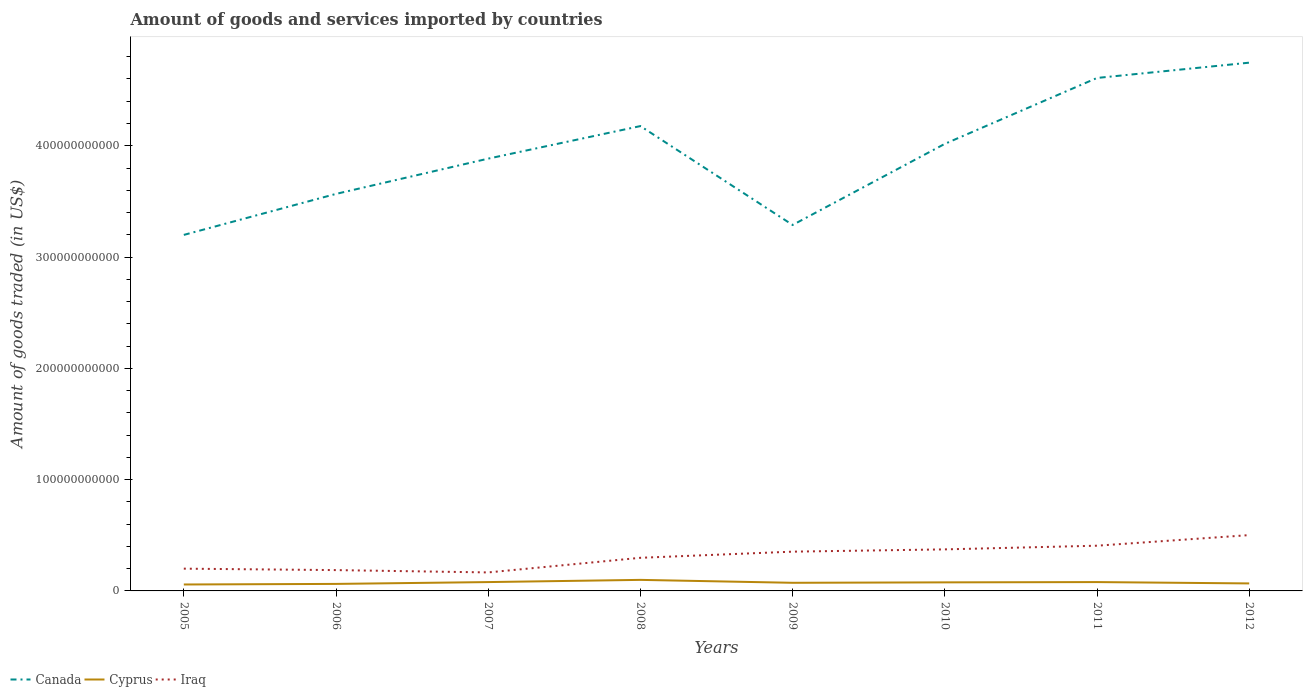How many different coloured lines are there?
Make the answer very short. 3. Is the number of lines equal to the number of legend labels?
Your answer should be compact. Yes. Across all years, what is the maximum total amount of goods and services imported in Iraq?
Your response must be concise. 1.66e+1. In which year was the total amount of goods and services imported in Canada maximum?
Keep it short and to the point. 2005. What is the total total amount of goods and services imported in Cyprus in the graph?
Give a very brief answer. -3.08e+06. What is the difference between the highest and the second highest total amount of goods and services imported in Iraq?
Give a very brief answer. 3.35e+1. Is the total amount of goods and services imported in Canada strictly greater than the total amount of goods and services imported in Iraq over the years?
Make the answer very short. No. What is the difference between two consecutive major ticks on the Y-axis?
Keep it short and to the point. 1.00e+11. Are the values on the major ticks of Y-axis written in scientific E-notation?
Your answer should be very brief. No. Does the graph contain any zero values?
Your answer should be very brief. No. Does the graph contain grids?
Provide a short and direct response. No. Where does the legend appear in the graph?
Your answer should be very brief. Bottom left. What is the title of the graph?
Your response must be concise. Amount of goods and services imported by countries. Does "Argentina" appear as one of the legend labels in the graph?
Offer a very short reply. No. What is the label or title of the X-axis?
Keep it short and to the point. Years. What is the label or title of the Y-axis?
Give a very brief answer. Amount of goods traded (in US$). What is the Amount of goods traded (in US$) of Canada in 2005?
Provide a succinct answer. 3.20e+11. What is the Amount of goods traded (in US$) of Cyprus in 2005?
Offer a very short reply. 5.79e+09. What is the Amount of goods traded (in US$) in Iraq in 2005?
Offer a terse response. 2.00e+1. What is the Amount of goods traded (in US$) of Canada in 2006?
Your response must be concise. 3.57e+11. What is the Amount of goods traded (in US$) of Cyprus in 2006?
Make the answer very short. 6.30e+09. What is the Amount of goods traded (in US$) of Iraq in 2006?
Give a very brief answer. 1.87e+1. What is the Amount of goods traded (in US$) in Canada in 2007?
Offer a terse response. 3.88e+11. What is the Amount of goods traded (in US$) of Cyprus in 2007?
Your answer should be compact. 7.95e+09. What is the Amount of goods traded (in US$) in Iraq in 2007?
Your answer should be very brief. 1.66e+1. What is the Amount of goods traded (in US$) in Canada in 2008?
Ensure brevity in your answer.  4.18e+11. What is the Amount of goods traded (in US$) of Cyprus in 2008?
Your answer should be compact. 9.93e+09. What is the Amount of goods traded (in US$) of Iraq in 2008?
Provide a short and direct response. 2.98e+1. What is the Amount of goods traded (in US$) of Canada in 2009?
Provide a short and direct response. 3.29e+11. What is the Amount of goods traded (in US$) of Cyprus in 2009?
Offer a very short reply. 7.30e+09. What is the Amount of goods traded (in US$) of Iraq in 2009?
Offer a very short reply. 3.53e+1. What is the Amount of goods traded (in US$) in Canada in 2010?
Your answer should be compact. 4.02e+11. What is the Amount of goods traded (in US$) in Cyprus in 2010?
Make the answer very short. 7.69e+09. What is the Amount of goods traded (in US$) of Iraq in 2010?
Provide a short and direct response. 3.73e+1. What is the Amount of goods traded (in US$) of Canada in 2011?
Your answer should be compact. 4.61e+11. What is the Amount of goods traded (in US$) in Cyprus in 2011?
Ensure brevity in your answer.  7.95e+09. What is the Amount of goods traded (in US$) of Iraq in 2011?
Your answer should be compact. 4.06e+1. What is the Amount of goods traded (in US$) in Canada in 2012?
Provide a short and direct response. 4.75e+11. What is the Amount of goods traded (in US$) in Cyprus in 2012?
Your answer should be compact. 6.74e+09. What is the Amount of goods traded (in US$) of Iraq in 2012?
Provide a succinct answer. 5.02e+1. Across all years, what is the maximum Amount of goods traded (in US$) in Canada?
Offer a very short reply. 4.75e+11. Across all years, what is the maximum Amount of goods traded (in US$) of Cyprus?
Provide a succinct answer. 9.93e+09. Across all years, what is the maximum Amount of goods traded (in US$) in Iraq?
Keep it short and to the point. 5.02e+1. Across all years, what is the minimum Amount of goods traded (in US$) of Canada?
Make the answer very short. 3.20e+11. Across all years, what is the minimum Amount of goods traded (in US$) in Cyprus?
Offer a terse response. 5.79e+09. Across all years, what is the minimum Amount of goods traded (in US$) in Iraq?
Your answer should be very brief. 1.66e+1. What is the total Amount of goods traded (in US$) of Canada in the graph?
Your answer should be very brief. 3.15e+12. What is the total Amount of goods traded (in US$) of Cyprus in the graph?
Your response must be concise. 5.96e+1. What is the total Amount of goods traded (in US$) in Iraq in the graph?
Offer a terse response. 2.48e+11. What is the difference between the Amount of goods traded (in US$) of Canada in 2005 and that in 2006?
Your response must be concise. -3.68e+1. What is the difference between the Amount of goods traded (in US$) of Cyprus in 2005 and that in 2006?
Give a very brief answer. -5.11e+08. What is the difference between the Amount of goods traded (in US$) in Iraq in 2005 and that in 2006?
Offer a terse response. 1.29e+09. What is the difference between the Amount of goods traded (in US$) of Canada in 2005 and that in 2007?
Your answer should be compact. -6.85e+1. What is the difference between the Amount of goods traded (in US$) of Cyprus in 2005 and that in 2007?
Keep it short and to the point. -2.16e+09. What is the difference between the Amount of goods traded (in US$) of Iraq in 2005 and that in 2007?
Make the answer very short. 3.38e+09. What is the difference between the Amount of goods traded (in US$) of Canada in 2005 and that in 2008?
Your response must be concise. -9.78e+1. What is the difference between the Amount of goods traded (in US$) of Cyprus in 2005 and that in 2008?
Offer a terse response. -4.15e+09. What is the difference between the Amount of goods traded (in US$) in Iraq in 2005 and that in 2008?
Your response must be concise. -9.76e+09. What is the difference between the Amount of goods traded (in US$) of Canada in 2005 and that in 2009?
Provide a short and direct response. -8.94e+09. What is the difference between the Amount of goods traded (in US$) in Cyprus in 2005 and that in 2009?
Your response must be concise. -1.51e+09. What is the difference between the Amount of goods traded (in US$) in Iraq in 2005 and that in 2009?
Your answer should be very brief. -1.53e+1. What is the difference between the Amount of goods traded (in US$) in Canada in 2005 and that in 2010?
Give a very brief answer. -8.18e+1. What is the difference between the Amount of goods traded (in US$) of Cyprus in 2005 and that in 2010?
Provide a succinct answer. -1.91e+09. What is the difference between the Amount of goods traded (in US$) in Iraq in 2005 and that in 2010?
Offer a very short reply. -1.73e+1. What is the difference between the Amount of goods traded (in US$) in Canada in 2005 and that in 2011?
Make the answer very short. -1.41e+11. What is the difference between the Amount of goods traded (in US$) in Cyprus in 2005 and that in 2011?
Give a very brief answer. -2.16e+09. What is the difference between the Amount of goods traded (in US$) of Iraq in 2005 and that in 2011?
Give a very brief answer. -2.06e+1. What is the difference between the Amount of goods traded (in US$) in Canada in 2005 and that in 2012?
Offer a terse response. -1.55e+11. What is the difference between the Amount of goods traded (in US$) of Cyprus in 2005 and that in 2012?
Your response must be concise. -9.59e+08. What is the difference between the Amount of goods traded (in US$) in Iraq in 2005 and that in 2012?
Keep it short and to the point. -3.02e+1. What is the difference between the Amount of goods traded (in US$) in Canada in 2006 and that in 2007?
Keep it short and to the point. -3.17e+1. What is the difference between the Amount of goods traded (in US$) of Cyprus in 2006 and that in 2007?
Offer a terse response. -1.65e+09. What is the difference between the Amount of goods traded (in US$) in Iraq in 2006 and that in 2007?
Your answer should be very brief. 2.08e+09. What is the difference between the Amount of goods traded (in US$) of Canada in 2006 and that in 2008?
Your response must be concise. -6.09e+1. What is the difference between the Amount of goods traded (in US$) in Cyprus in 2006 and that in 2008?
Provide a short and direct response. -3.63e+09. What is the difference between the Amount of goods traded (in US$) of Iraq in 2006 and that in 2008?
Provide a short and direct response. -1.11e+1. What is the difference between the Amount of goods traded (in US$) in Canada in 2006 and that in 2009?
Offer a terse response. 2.79e+1. What is the difference between the Amount of goods traded (in US$) of Cyprus in 2006 and that in 2009?
Offer a terse response. -1.00e+09. What is the difference between the Amount of goods traded (in US$) in Iraq in 2006 and that in 2009?
Offer a terse response. -1.66e+1. What is the difference between the Amount of goods traded (in US$) of Canada in 2006 and that in 2010?
Offer a terse response. -4.50e+1. What is the difference between the Amount of goods traded (in US$) of Cyprus in 2006 and that in 2010?
Your answer should be compact. -1.40e+09. What is the difference between the Amount of goods traded (in US$) of Iraq in 2006 and that in 2010?
Give a very brief answer. -1.86e+1. What is the difference between the Amount of goods traded (in US$) of Canada in 2006 and that in 2011?
Offer a very short reply. -1.04e+11. What is the difference between the Amount of goods traded (in US$) in Cyprus in 2006 and that in 2011?
Provide a succinct answer. -1.65e+09. What is the difference between the Amount of goods traded (in US$) of Iraq in 2006 and that in 2011?
Your answer should be very brief. -2.19e+1. What is the difference between the Amount of goods traded (in US$) in Canada in 2006 and that in 2012?
Provide a short and direct response. -1.18e+11. What is the difference between the Amount of goods traded (in US$) of Cyprus in 2006 and that in 2012?
Ensure brevity in your answer.  -4.48e+08. What is the difference between the Amount of goods traded (in US$) in Iraq in 2006 and that in 2012?
Ensure brevity in your answer.  -3.14e+1. What is the difference between the Amount of goods traded (in US$) of Canada in 2007 and that in 2008?
Offer a very short reply. -2.92e+1. What is the difference between the Amount of goods traded (in US$) of Cyprus in 2007 and that in 2008?
Offer a very short reply. -1.98e+09. What is the difference between the Amount of goods traded (in US$) of Iraq in 2007 and that in 2008?
Provide a short and direct response. -1.31e+1. What is the difference between the Amount of goods traded (in US$) in Canada in 2007 and that in 2009?
Give a very brief answer. 5.96e+1. What is the difference between the Amount of goods traded (in US$) of Cyprus in 2007 and that in 2009?
Your answer should be compact. 6.48e+08. What is the difference between the Amount of goods traded (in US$) in Iraq in 2007 and that in 2009?
Your answer should be very brief. -1.87e+1. What is the difference between the Amount of goods traded (in US$) of Canada in 2007 and that in 2010?
Offer a terse response. -1.33e+1. What is the difference between the Amount of goods traded (in US$) of Cyprus in 2007 and that in 2010?
Your answer should be compact. 2.55e+08. What is the difference between the Amount of goods traded (in US$) in Iraq in 2007 and that in 2010?
Give a very brief answer. -2.07e+1. What is the difference between the Amount of goods traded (in US$) in Canada in 2007 and that in 2011?
Your response must be concise. -7.25e+1. What is the difference between the Amount of goods traded (in US$) of Cyprus in 2007 and that in 2011?
Your response must be concise. -3.08e+06. What is the difference between the Amount of goods traded (in US$) in Iraq in 2007 and that in 2011?
Keep it short and to the point. -2.40e+1. What is the difference between the Amount of goods traded (in US$) in Canada in 2007 and that in 2012?
Keep it short and to the point. -8.62e+1. What is the difference between the Amount of goods traded (in US$) of Cyprus in 2007 and that in 2012?
Your answer should be compact. 1.20e+09. What is the difference between the Amount of goods traded (in US$) of Iraq in 2007 and that in 2012?
Keep it short and to the point. -3.35e+1. What is the difference between the Amount of goods traded (in US$) in Canada in 2008 and that in 2009?
Offer a very short reply. 8.88e+1. What is the difference between the Amount of goods traded (in US$) in Cyprus in 2008 and that in 2009?
Your answer should be very brief. 2.63e+09. What is the difference between the Amount of goods traded (in US$) in Iraq in 2008 and that in 2009?
Give a very brief answer. -5.52e+09. What is the difference between the Amount of goods traded (in US$) in Canada in 2008 and that in 2010?
Keep it short and to the point. 1.60e+1. What is the difference between the Amount of goods traded (in US$) of Cyprus in 2008 and that in 2010?
Offer a terse response. 2.24e+09. What is the difference between the Amount of goods traded (in US$) in Iraq in 2008 and that in 2010?
Your response must be concise. -7.57e+09. What is the difference between the Amount of goods traded (in US$) in Canada in 2008 and that in 2011?
Offer a terse response. -4.32e+1. What is the difference between the Amount of goods traded (in US$) in Cyprus in 2008 and that in 2011?
Provide a short and direct response. 1.98e+09. What is the difference between the Amount of goods traded (in US$) in Iraq in 2008 and that in 2011?
Your response must be concise. -1.09e+1. What is the difference between the Amount of goods traded (in US$) of Canada in 2008 and that in 2012?
Offer a terse response. -5.70e+1. What is the difference between the Amount of goods traded (in US$) of Cyprus in 2008 and that in 2012?
Offer a terse response. 3.19e+09. What is the difference between the Amount of goods traded (in US$) in Iraq in 2008 and that in 2012?
Offer a very short reply. -2.04e+1. What is the difference between the Amount of goods traded (in US$) in Canada in 2009 and that in 2010?
Give a very brief answer. -7.29e+1. What is the difference between the Amount of goods traded (in US$) in Cyprus in 2009 and that in 2010?
Provide a succinct answer. -3.93e+08. What is the difference between the Amount of goods traded (in US$) of Iraq in 2009 and that in 2010?
Give a very brief answer. -2.04e+09. What is the difference between the Amount of goods traded (in US$) of Canada in 2009 and that in 2011?
Your answer should be very brief. -1.32e+11. What is the difference between the Amount of goods traded (in US$) of Cyprus in 2009 and that in 2011?
Your response must be concise. -6.51e+08. What is the difference between the Amount of goods traded (in US$) in Iraq in 2009 and that in 2011?
Your answer should be very brief. -5.35e+09. What is the difference between the Amount of goods traded (in US$) in Canada in 2009 and that in 2012?
Your answer should be compact. -1.46e+11. What is the difference between the Amount of goods traded (in US$) in Cyprus in 2009 and that in 2012?
Your answer should be very brief. 5.55e+08. What is the difference between the Amount of goods traded (in US$) in Iraq in 2009 and that in 2012?
Provide a short and direct response. -1.49e+1. What is the difference between the Amount of goods traded (in US$) in Canada in 2010 and that in 2011?
Provide a succinct answer. -5.92e+1. What is the difference between the Amount of goods traded (in US$) of Cyprus in 2010 and that in 2011?
Give a very brief answer. -2.58e+08. What is the difference between the Amount of goods traded (in US$) of Iraq in 2010 and that in 2011?
Give a very brief answer. -3.30e+09. What is the difference between the Amount of goods traded (in US$) in Canada in 2010 and that in 2012?
Provide a short and direct response. -7.29e+1. What is the difference between the Amount of goods traded (in US$) of Cyprus in 2010 and that in 2012?
Ensure brevity in your answer.  9.48e+08. What is the difference between the Amount of goods traded (in US$) of Iraq in 2010 and that in 2012?
Your answer should be compact. -1.28e+1. What is the difference between the Amount of goods traded (in US$) in Canada in 2011 and that in 2012?
Your response must be concise. -1.37e+1. What is the difference between the Amount of goods traded (in US$) in Cyprus in 2011 and that in 2012?
Your answer should be compact. 1.21e+09. What is the difference between the Amount of goods traded (in US$) in Iraq in 2011 and that in 2012?
Give a very brief answer. -9.52e+09. What is the difference between the Amount of goods traded (in US$) in Canada in 2005 and the Amount of goods traded (in US$) in Cyprus in 2006?
Ensure brevity in your answer.  3.14e+11. What is the difference between the Amount of goods traded (in US$) of Canada in 2005 and the Amount of goods traded (in US$) of Iraq in 2006?
Give a very brief answer. 3.01e+11. What is the difference between the Amount of goods traded (in US$) of Cyprus in 2005 and the Amount of goods traded (in US$) of Iraq in 2006?
Your response must be concise. -1.29e+1. What is the difference between the Amount of goods traded (in US$) of Canada in 2005 and the Amount of goods traded (in US$) of Cyprus in 2007?
Offer a terse response. 3.12e+11. What is the difference between the Amount of goods traded (in US$) of Canada in 2005 and the Amount of goods traded (in US$) of Iraq in 2007?
Your answer should be very brief. 3.03e+11. What is the difference between the Amount of goods traded (in US$) in Cyprus in 2005 and the Amount of goods traded (in US$) in Iraq in 2007?
Ensure brevity in your answer.  -1.08e+1. What is the difference between the Amount of goods traded (in US$) in Canada in 2005 and the Amount of goods traded (in US$) in Cyprus in 2008?
Your answer should be very brief. 3.10e+11. What is the difference between the Amount of goods traded (in US$) of Canada in 2005 and the Amount of goods traded (in US$) of Iraq in 2008?
Offer a very short reply. 2.90e+11. What is the difference between the Amount of goods traded (in US$) in Cyprus in 2005 and the Amount of goods traded (in US$) in Iraq in 2008?
Your response must be concise. -2.40e+1. What is the difference between the Amount of goods traded (in US$) of Canada in 2005 and the Amount of goods traded (in US$) of Cyprus in 2009?
Your answer should be compact. 3.13e+11. What is the difference between the Amount of goods traded (in US$) of Canada in 2005 and the Amount of goods traded (in US$) of Iraq in 2009?
Your response must be concise. 2.85e+11. What is the difference between the Amount of goods traded (in US$) in Cyprus in 2005 and the Amount of goods traded (in US$) in Iraq in 2009?
Your answer should be compact. -2.95e+1. What is the difference between the Amount of goods traded (in US$) of Canada in 2005 and the Amount of goods traded (in US$) of Cyprus in 2010?
Make the answer very short. 3.12e+11. What is the difference between the Amount of goods traded (in US$) in Canada in 2005 and the Amount of goods traded (in US$) in Iraq in 2010?
Offer a very short reply. 2.83e+11. What is the difference between the Amount of goods traded (in US$) of Cyprus in 2005 and the Amount of goods traded (in US$) of Iraq in 2010?
Provide a short and direct response. -3.15e+1. What is the difference between the Amount of goods traded (in US$) in Canada in 2005 and the Amount of goods traded (in US$) in Cyprus in 2011?
Offer a terse response. 3.12e+11. What is the difference between the Amount of goods traded (in US$) of Canada in 2005 and the Amount of goods traded (in US$) of Iraq in 2011?
Provide a succinct answer. 2.79e+11. What is the difference between the Amount of goods traded (in US$) in Cyprus in 2005 and the Amount of goods traded (in US$) in Iraq in 2011?
Provide a succinct answer. -3.48e+1. What is the difference between the Amount of goods traded (in US$) in Canada in 2005 and the Amount of goods traded (in US$) in Cyprus in 2012?
Give a very brief answer. 3.13e+11. What is the difference between the Amount of goods traded (in US$) of Canada in 2005 and the Amount of goods traded (in US$) of Iraq in 2012?
Give a very brief answer. 2.70e+11. What is the difference between the Amount of goods traded (in US$) of Cyprus in 2005 and the Amount of goods traded (in US$) of Iraq in 2012?
Offer a very short reply. -4.44e+1. What is the difference between the Amount of goods traded (in US$) of Canada in 2006 and the Amount of goods traded (in US$) of Cyprus in 2007?
Provide a short and direct response. 3.49e+11. What is the difference between the Amount of goods traded (in US$) in Canada in 2006 and the Amount of goods traded (in US$) in Iraq in 2007?
Offer a terse response. 3.40e+11. What is the difference between the Amount of goods traded (in US$) of Cyprus in 2006 and the Amount of goods traded (in US$) of Iraq in 2007?
Provide a succinct answer. -1.03e+1. What is the difference between the Amount of goods traded (in US$) in Canada in 2006 and the Amount of goods traded (in US$) in Cyprus in 2008?
Your answer should be very brief. 3.47e+11. What is the difference between the Amount of goods traded (in US$) in Canada in 2006 and the Amount of goods traded (in US$) in Iraq in 2008?
Provide a succinct answer. 3.27e+11. What is the difference between the Amount of goods traded (in US$) of Cyprus in 2006 and the Amount of goods traded (in US$) of Iraq in 2008?
Your answer should be very brief. -2.35e+1. What is the difference between the Amount of goods traded (in US$) in Canada in 2006 and the Amount of goods traded (in US$) in Cyprus in 2009?
Provide a succinct answer. 3.49e+11. What is the difference between the Amount of goods traded (in US$) of Canada in 2006 and the Amount of goods traded (in US$) of Iraq in 2009?
Keep it short and to the point. 3.21e+11. What is the difference between the Amount of goods traded (in US$) of Cyprus in 2006 and the Amount of goods traded (in US$) of Iraq in 2009?
Provide a short and direct response. -2.90e+1. What is the difference between the Amount of goods traded (in US$) in Canada in 2006 and the Amount of goods traded (in US$) in Cyprus in 2010?
Give a very brief answer. 3.49e+11. What is the difference between the Amount of goods traded (in US$) in Canada in 2006 and the Amount of goods traded (in US$) in Iraq in 2010?
Offer a terse response. 3.19e+11. What is the difference between the Amount of goods traded (in US$) of Cyprus in 2006 and the Amount of goods traded (in US$) of Iraq in 2010?
Keep it short and to the point. -3.10e+1. What is the difference between the Amount of goods traded (in US$) in Canada in 2006 and the Amount of goods traded (in US$) in Cyprus in 2011?
Your answer should be compact. 3.49e+11. What is the difference between the Amount of goods traded (in US$) of Canada in 2006 and the Amount of goods traded (in US$) of Iraq in 2011?
Your answer should be very brief. 3.16e+11. What is the difference between the Amount of goods traded (in US$) in Cyprus in 2006 and the Amount of goods traded (in US$) in Iraq in 2011?
Your answer should be compact. -3.43e+1. What is the difference between the Amount of goods traded (in US$) of Canada in 2006 and the Amount of goods traded (in US$) of Cyprus in 2012?
Your answer should be very brief. 3.50e+11. What is the difference between the Amount of goods traded (in US$) of Canada in 2006 and the Amount of goods traded (in US$) of Iraq in 2012?
Provide a short and direct response. 3.07e+11. What is the difference between the Amount of goods traded (in US$) in Cyprus in 2006 and the Amount of goods traded (in US$) in Iraq in 2012?
Ensure brevity in your answer.  -4.39e+1. What is the difference between the Amount of goods traded (in US$) of Canada in 2007 and the Amount of goods traded (in US$) of Cyprus in 2008?
Your response must be concise. 3.78e+11. What is the difference between the Amount of goods traded (in US$) in Canada in 2007 and the Amount of goods traded (in US$) in Iraq in 2008?
Offer a terse response. 3.59e+11. What is the difference between the Amount of goods traded (in US$) of Cyprus in 2007 and the Amount of goods traded (in US$) of Iraq in 2008?
Offer a terse response. -2.18e+1. What is the difference between the Amount of goods traded (in US$) in Canada in 2007 and the Amount of goods traded (in US$) in Cyprus in 2009?
Provide a short and direct response. 3.81e+11. What is the difference between the Amount of goods traded (in US$) in Canada in 2007 and the Amount of goods traded (in US$) in Iraq in 2009?
Provide a short and direct response. 3.53e+11. What is the difference between the Amount of goods traded (in US$) of Cyprus in 2007 and the Amount of goods traded (in US$) of Iraq in 2009?
Your answer should be compact. -2.73e+1. What is the difference between the Amount of goods traded (in US$) of Canada in 2007 and the Amount of goods traded (in US$) of Cyprus in 2010?
Your answer should be compact. 3.81e+11. What is the difference between the Amount of goods traded (in US$) in Canada in 2007 and the Amount of goods traded (in US$) in Iraq in 2010?
Provide a succinct answer. 3.51e+11. What is the difference between the Amount of goods traded (in US$) of Cyprus in 2007 and the Amount of goods traded (in US$) of Iraq in 2010?
Ensure brevity in your answer.  -2.94e+1. What is the difference between the Amount of goods traded (in US$) of Canada in 2007 and the Amount of goods traded (in US$) of Cyprus in 2011?
Keep it short and to the point. 3.80e+11. What is the difference between the Amount of goods traded (in US$) in Canada in 2007 and the Amount of goods traded (in US$) in Iraq in 2011?
Give a very brief answer. 3.48e+11. What is the difference between the Amount of goods traded (in US$) of Cyprus in 2007 and the Amount of goods traded (in US$) of Iraq in 2011?
Provide a short and direct response. -3.27e+1. What is the difference between the Amount of goods traded (in US$) of Canada in 2007 and the Amount of goods traded (in US$) of Cyprus in 2012?
Your answer should be very brief. 3.82e+11. What is the difference between the Amount of goods traded (in US$) in Canada in 2007 and the Amount of goods traded (in US$) in Iraq in 2012?
Provide a short and direct response. 3.38e+11. What is the difference between the Amount of goods traded (in US$) of Cyprus in 2007 and the Amount of goods traded (in US$) of Iraq in 2012?
Offer a terse response. -4.22e+1. What is the difference between the Amount of goods traded (in US$) in Canada in 2008 and the Amount of goods traded (in US$) in Cyprus in 2009?
Ensure brevity in your answer.  4.10e+11. What is the difference between the Amount of goods traded (in US$) in Canada in 2008 and the Amount of goods traded (in US$) in Iraq in 2009?
Offer a terse response. 3.82e+11. What is the difference between the Amount of goods traded (in US$) in Cyprus in 2008 and the Amount of goods traded (in US$) in Iraq in 2009?
Give a very brief answer. -2.54e+1. What is the difference between the Amount of goods traded (in US$) in Canada in 2008 and the Amount of goods traded (in US$) in Cyprus in 2010?
Keep it short and to the point. 4.10e+11. What is the difference between the Amount of goods traded (in US$) of Canada in 2008 and the Amount of goods traded (in US$) of Iraq in 2010?
Your response must be concise. 3.80e+11. What is the difference between the Amount of goods traded (in US$) in Cyprus in 2008 and the Amount of goods traded (in US$) in Iraq in 2010?
Give a very brief answer. -2.74e+1. What is the difference between the Amount of goods traded (in US$) in Canada in 2008 and the Amount of goods traded (in US$) in Cyprus in 2011?
Make the answer very short. 4.10e+11. What is the difference between the Amount of goods traded (in US$) in Canada in 2008 and the Amount of goods traded (in US$) in Iraq in 2011?
Offer a very short reply. 3.77e+11. What is the difference between the Amount of goods traded (in US$) in Cyprus in 2008 and the Amount of goods traded (in US$) in Iraq in 2011?
Provide a succinct answer. -3.07e+1. What is the difference between the Amount of goods traded (in US$) in Canada in 2008 and the Amount of goods traded (in US$) in Cyprus in 2012?
Keep it short and to the point. 4.11e+11. What is the difference between the Amount of goods traded (in US$) of Canada in 2008 and the Amount of goods traded (in US$) of Iraq in 2012?
Your answer should be compact. 3.68e+11. What is the difference between the Amount of goods traded (in US$) in Cyprus in 2008 and the Amount of goods traded (in US$) in Iraq in 2012?
Your answer should be compact. -4.02e+1. What is the difference between the Amount of goods traded (in US$) in Canada in 2009 and the Amount of goods traded (in US$) in Cyprus in 2010?
Your answer should be compact. 3.21e+11. What is the difference between the Amount of goods traded (in US$) of Canada in 2009 and the Amount of goods traded (in US$) of Iraq in 2010?
Offer a terse response. 2.92e+11. What is the difference between the Amount of goods traded (in US$) in Cyprus in 2009 and the Amount of goods traded (in US$) in Iraq in 2010?
Keep it short and to the point. -3.00e+1. What is the difference between the Amount of goods traded (in US$) in Canada in 2009 and the Amount of goods traded (in US$) in Cyprus in 2011?
Your answer should be very brief. 3.21e+11. What is the difference between the Amount of goods traded (in US$) in Canada in 2009 and the Amount of goods traded (in US$) in Iraq in 2011?
Offer a very short reply. 2.88e+11. What is the difference between the Amount of goods traded (in US$) in Cyprus in 2009 and the Amount of goods traded (in US$) in Iraq in 2011?
Ensure brevity in your answer.  -3.33e+1. What is the difference between the Amount of goods traded (in US$) of Canada in 2009 and the Amount of goods traded (in US$) of Cyprus in 2012?
Your answer should be compact. 3.22e+11. What is the difference between the Amount of goods traded (in US$) in Canada in 2009 and the Amount of goods traded (in US$) in Iraq in 2012?
Your answer should be very brief. 2.79e+11. What is the difference between the Amount of goods traded (in US$) of Cyprus in 2009 and the Amount of goods traded (in US$) of Iraq in 2012?
Provide a short and direct response. -4.29e+1. What is the difference between the Amount of goods traded (in US$) of Canada in 2010 and the Amount of goods traded (in US$) of Cyprus in 2011?
Offer a terse response. 3.94e+11. What is the difference between the Amount of goods traded (in US$) of Canada in 2010 and the Amount of goods traded (in US$) of Iraq in 2011?
Ensure brevity in your answer.  3.61e+11. What is the difference between the Amount of goods traded (in US$) in Cyprus in 2010 and the Amount of goods traded (in US$) in Iraq in 2011?
Your response must be concise. -3.29e+1. What is the difference between the Amount of goods traded (in US$) in Canada in 2010 and the Amount of goods traded (in US$) in Cyprus in 2012?
Provide a succinct answer. 3.95e+11. What is the difference between the Amount of goods traded (in US$) in Canada in 2010 and the Amount of goods traded (in US$) in Iraq in 2012?
Your answer should be very brief. 3.52e+11. What is the difference between the Amount of goods traded (in US$) in Cyprus in 2010 and the Amount of goods traded (in US$) in Iraq in 2012?
Offer a very short reply. -4.25e+1. What is the difference between the Amount of goods traded (in US$) of Canada in 2011 and the Amount of goods traded (in US$) of Cyprus in 2012?
Your answer should be compact. 4.54e+11. What is the difference between the Amount of goods traded (in US$) in Canada in 2011 and the Amount of goods traded (in US$) in Iraq in 2012?
Your response must be concise. 4.11e+11. What is the difference between the Amount of goods traded (in US$) in Cyprus in 2011 and the Amount of goods traded (in US$) in Iraq in 2012?
Provide a short and direct response. -4.22e+1. What is the average Amount of goods traded (in US$) in Canada per year?
Provide a short and direct response. 3.94e+11. What is the average Amount of goods traded (in US$) in Cyprus per year?
Offer a very short reply. 7.46e+09. What is the average Amount of goods traded (in US$) in Iraq per year?
Your response must be concise. 3.11e+1. In the year 2005, what is the difference between the Amount of goods traded (in US$) in Canada and Amount of goods traded (in US$) in Cyprus?
Keep it short and to the point. 3.14e+11. In the year 2005, what is the difference between the Amount of goods traded (in US$) of Canada and Amount of goods traded (in US$) of Iraq?
Offer a very short reply. 3.00e+11. In the year 2005, what is the difference between the Amount of goods traded (in US$) in Cyprus and Amount of goods traded (in US$) in Iraq?
Give a very brief answer. -1.42e+1. In the year 2006, what is the difference between the Amount of goods traded (in US$) of Canada and Amount of goods traded (in US$) of Cyprus?
Your answer should be very brief. 3.50e+11. In the year 2006, what is the difference between the Amount of goods traded (in US$) of Canada and Amount of goods traded (in US$) of Iraq?
Give a very brief answer. 3.38e+11. In the year 2006, what is the difference between the Amount of goods traded (in US$) in Cyprus and Amount of goods traded (in US$) in Iraq?
Offer a very short reply. -1.24e+1. In the year 2007, what is the difference between the Amount of goods traded (in US$) in Canada and Amount of goods traded (in US$) in Cyprus?
Provide a short and direct response. 3.80e+11. In the year 2007, what is the difference between the Amount of goods traded (in US$) of Canada and Amount of goods traded (in US$) of Iraq?
Provide a succinct answer. 3.72e+11. In the year 2007, what is the difference between the Amount of goods traded (in US$) of Cyprus and Amount of goods traded (in US$) of Iraq?
Your answer should be compact. -8.68e+09. In the year 2008, what is the difference between the Amount of goods traded (in US$) in Canada and Amount of goods traded (in US$) in Cyprus?
Make the answer very short. 4.08e+11. In the year 2008, what is the difference between the Amount of goods traded (in US$) of Canada and Amount of goods traded (in US$) of Iraq?
Offer a very short reply. 3.88e+11. In the year 2008, what is the difference between the Amount of goods traded (in US$) in Cyprus and Amount of goods traded (in US$) in Iraq?
Offer a very short reply. -1.98e+1. In the year 2009, what is the difference between the Amount of goods traded (in US$) of Canada and Amount of goods traded (in US$) of Cyprus?
Your response must be concise. 3.22e+11. In the year 2009, what is the difference between the Amount of goods traded (in US$) of Canada and Amount of goods traded (in US$) of Iraq?
Your response must be concise. 2.94e+11. In the year 2009, what is the difference between the Amount of goods traded (in US$) in Cyprus and Amount of goods traded (in US$) in Iraq?
Keep it short and to the point. -2.80e+1. In the year 2010, what is the difference between the Amount of goods traded (in US$) in Canada and Amount of goods traded (in US$) in Cyprus?
Give a very brief answer. 3.94e+11. In the year 2010, what is the difference between the Amount of goods traded (in US$) of Canada and Amount of goods traded (in US$) of Iraq?
Make the answer very short. 3.64e+11. In the year 2010, what is the difference between the Amount of goods traded (in US$) in Cyprus and Amount of goods traded (in US$) in Iraq?
Provide a short and direct response. -2.96e+1. In the year 2011, what is the difference between the Amount of goods traded (in US$) in Canada and Amount of goods traded (in US$) in Cyprus?
Provide a succinct answer. 4.53e+11. In the year 2011, what is the difference between the Amount of goods traded (in US$) in Canada and Amount of goods traded (in US$) in Iraq?
Your answer should be compact. 4.20e+11. In the year 2011, what is the difference between the Amount of goods traded (in US$) in Cyprus and Amount of goods traded (in US$) in Iraq?
Offer a very short reply. -3.27e+1. In the year 2012, what is the difference between the Amount of goods traded (in US$) in Canada and Amount of goods traded (in US$) in Cyprus?
Provide a short and direct response. 4.68e+11. In the year 2012, what is the difference between the Amount of goods traded (in US$) in Canada and Amount of goods traded (in US$) in Iraq?
Keep it short and to the point. 4.24e+11. In the year 2012, what is the difference between the Amount of goods traded (in US$) of Cyprus and Amount of goods traded (in US$) of Iraq?
Ensure brevity in your answer.  -4.34e+1. What is the ratio of the Amount of goods traded (in US$) in Canada in 2005 to that in 2006?
Your response must be concise. 0.9. What is the ratio of the Amount of goods traded (in US$) of Cyprus in 2005 to that in 2006?
Provide a short and direct response. 0.92. What is the ratio of the Amount of goods traded (in US$) in Iraq in 2005 to that in 2006?
Keep it short and to the point. 1.07. What is the ratio of the Amount of goods traded (in US$) in Canada in 2005 to that in 2007?
Your answer should be very brief. 0.82. What is the ratio of the Amount of goods traded (in US$) of Cyprus in 2005 to that in 2007?
Your answer should be compact. 0.73. What is the ratio of the Amount of goods traded (in US$) in Iraq in 2005 to that in 2007?
Give a very brief answer. 1.2. What is the ratio of the Amount of goods traded (in US$) of Canada in 2005 to that in 2008?
Offer a terse response. 0.77. What is the ratio of the Amount of goods traded (in US$) in Cyprus in 2005 to that in 2008?
Your answer should be compact. 0.58. What is the ratio of the Amount of goods traded (in US$) of Iraq in 2005 to that in 2008?
Your response must be concise. 0.67. What is the ratio of the Amount of goods traded (in US$) of Canada in 2005 to that in 2009?
Offer a very short reply. 0.97. What is the ratio of the Amount of goods traded (in US$) in Cyprus in 2005 to that in 2009?
Your response must be concise. 0.79. What is the ratio of the Amount of goods traded (in US$) in Iraq in 2005 to that in 2009?
Your response must be concise. 0.57. What is the ratio of the Amount of goods traded (in US$) of Canada in 2005 to that in 2010?
Your answer should be very brief. 0.8. What is the ratio of the Amount of goods traded (in US$) of Cyprus in 2005 to that in 2010?
Your response must be concise. 0.75. What is the ratio of the Amount of goods traded (in US$) of Iraq in 2005 to that in 2010?
Make the answer very short. 0.54. What is the ratio of the Amount of goods traded (in US$) in Canada in 2005 to that in 2011?
Offer a terse response. 0.69. What is the ratio of the Amount of goods traded (in US$) in Cyprus in 2005 to that in 2011?
Provide a succinct answer. 0.73. What is the ratio of the Amount of goods traded (in US$) in Iraq in 2005 to that in 2011?
Your response must be concise. 0.49. What is the ratio of the Amount of goods traded (in US$) of Canada in 2005 to that in 2012?
Your answer should be very brief. 0.67. What is the ratio of the Amount of goods traded (in US$) in Cyprus in 2005 to that in 2012?
Make the answer very short. 0.86. What is the ratio of the Amount of goods traded (in US$) in Iraq in 2005 to that in 2012?
Offer a terse response. 0.4. What is the ratio of the Amount of goods traded (in US$) in Canada in 2006 to that in 2007?
Keep it short and to the point. 0.92. What is the ratio of the Amount of goods traded (in US$) in Cyprus in 2006 to that in 2007?
Ensure brevity in your answer.  0.79. What is the ratio of the Amount of goods traded (in US$) of Iraq in 2006 to that in 2007?
Offer a terse response. 1.13. What is the ratio of the Amount of goods traded (in US$) of Canada in 2006 to that in 2008?
Make the answer very short. 0.85. What is the ratio of the Amount of goods traded (in US$) of Cyprus in 2006 to that in 2008?
Provide a short and direct response. 0.63. What is the ratio of the Amount of goods traded (in US$) of Iraq in 2006 to that in 2008?
Your response must be concise. 0.63. What is the ratio of the Amount of goods traded (in US$) of Canada in 2006 to that in 2009?
Your answer should be very brief. 1.08. What is the ratio of the Amount of goods traded (in US$) in Cyprus in 2006 to that in 2009?
Provide a short and direct response. 0.86. What is the ratio of the Amount of goods traded (in US$) of Iraq in 2006 to that in 2009?
Give a very brief answer. 0.53. What is the ratio of the Amount of goods traded (in US$) of Canada in 2006 to that in 2010?
Your answer should be very brief. 0.89. What is the ratio of the Amount of goods traded (in US$) of Cyprus in 2006 to that in 2010?
Your response must be concise. 0.82. What is the ratio of the Amount of goods traded (in US$) in Iraq in 2006 to that in 2010?
Make the answer very short. 0.5. What is the ratio of the Amount of goods traded (in US$) in Canada in 2006 to that in 2011?
Offer a very short reply. 0.77. What is the ratio of the Amount of goods traded (in US$) in Cyprus in 2006 to that in 2011?
Offer a very short reply. 0.79. What is the ratio of the Amount of goods traded (in US$) in Iraq in 2006 to that in 2011?
Your answer should be compact. 0.46. What is the ratio of the Amount of goods traded (in US$) in Canada in 2006 to that in 2012?
Ensure brevity in your answer.  0.75. What is the ratio of the Amount of goods traded (in US$) of Cyprus in 2006 to that in 2012?
Your answer should be compact. 0.93. What is the ratio of the Amount of goods traded (in US$) in Iraq in 2006 to that in 2012?
Offer a very short reply. 0.37. What is the ratio of the Amount of goods traded (in US$) of Cyprus in 2007 to that in 2008?
Keep it short and to the point. 0.8. What is the ratio of the Amount of goods traded (in US$) in Iraq in 2007 to that in 2008?
Your answer should be very brief. 0.56. What is the ratio of the Amount of goods traded (in US$) of Canada in 2007 to that in 2009?
Keep it short and to the point. 1.18. What is the ratio of the Amount of goods traded (in US$) of Cyprus in 2007 to that in 2009?
Provide a short and direct response. 1.09. What is the ratio of the Amount of goods traded (in US$) of Iraq in 2007 to that in 2009?
Ensure brevity in your answer.  0.47. What is the ratio of the Amount of goods traded (in US$) of Canada in 2007 to that in 2010?
Offer a terse response. 0.97. What is the ratio of the Amount of goods traded (in US$) of Cyprus in 2007 to that in 2010?
Make the answer very short. 1.03. What is the ratio of the Amount of goods traded (in US$) in Iraq in 2007 to that in 2010?
Your response must be concise. 0.45. What is the ratio of the Amount of goods traded (in US$) of Canada in 2007 to that in 2011?
Your answer should be very brief. 0.84. What is the ratio of the Amount of goods traded (in US$) of Cyprus in 2007 to that in 2011?
Provide a short and direct response. 1. What is the ratio of the Amount of goods traded (in US$) in Iraq in 2007 to that in 2011?
Provide a succinct answer. 0.41. What is the ratio of the Amount of goods traded (in US$) in Canada in 2007 to that in 2012?
Your answer should be very brief. 0.82. What is the ratio of the Amount of goods traded (in US$) of Cyprus in 2007 to that in 2012?
Your answer should be compact. 1.18. What is the ratio of the Amount of goods traded (in US$) in Iraq in 2007 to that in 2012?
Give a very brief answer. 0.33. What is the ratio of the Amount of goods traded (in US$) of Canada in 2008 to that in 2009?
Your answer should be very brief. 1.27. What is the ratio of the Amount of goods traded (in US$) of Cyprus in 2008 to that in 2009?
Offer a very short reply. 1.36. What is the ratio of the Amount of goods traded (in US$) of Iraq in 2008 to that in 2009?
Ensure brevity in your answer.  0.84. What is the ratio of the Amount of goods traded (in US$) of Canada in 2008 to that in 2010?
Your response must be concise. 1.04. What is the ratio of the Amount of goods traded (in US$) of Cyprus in 2008 to that in 2010?
Give a very brief answer. 1.29. What is the ratio of the Amount of goods traded (in US$) in Iraq in 2008 to that in 2010?
Your answer should be compact. 0.8. What is the ratio of the Amount of goods traded (in US$) of Canada in 2008 to that in 2011?
Keep it short and to the point. 0.91. What is the ratio of the Amount of goods traded (in US$) of Cyprus in 2008 to that in 2011?
Provide a short and direct response. 1.25. What is the ratio of the Amount of goods traded (in US$) in Iraq in 2008 to that in 2011?
Your answer should be compact. 0.73. What is the ratio of the Amount of goods traded (in US$) of Cyprus in 2008 to that in 2012?
Ensure brevity in your answer.  1.47. What is the ratio of the Amount of goods traded (in US$) of Iraq in 2008 to that in 2012?
Keep it short and to the point. 0.59. What is the ratio of the Amount of goods traded (in US$) in Canada in 2009 to that in 2010?
Your answer should be compact. 0.82. What is the ratio of the Amount of goods traded (in US$) in Cyprus in 2009 to that in 2010?
Make the answer very short. 0.95. What is the ratio of the Amount of goods traded (in US$) of Iraq in 2009 to that in 2010?
Offer a terse response. 0.95. What is the ratio of the Amount of goods traded (in US$) in Canada in 2009 to that in 2011?
Your response must be concise. 0.71. What is the ratio of the Amount of goods traded (in US$) of Cyprus in 2009 to that in 2011?
Offer a very short reply. 0.92. What is the ratio of the Amount of goods traded (in US$) of Iraq in 2009 to that in 2011?
Provide a succinct answer. 0.87. What is the ratio of the Amount of goods traded (in US$) of Canada in 2009 to that in 2012?
Make the answer very short. 0.69. What is the ratio of the Amount of goods traded (in US$) in Cyprus in 2009 to that in 2012?
Provide a succinct answer. 1.08. What is the ratio of the Amount of goods traded (in US$) in Iraq in 2009 to that in 2012?
Your answer should be compact. 0.7. What is the ratio of the Amount of goods traded (in US$) of Canada in 2010 to that in 2011?
Make the answer very short. 0.87. What is the ratio of the Amount of goods traded (in US$) of Cyprus in 2010 to that in 2011?
Give a very brief answer. 0.97. What is the ratio of the Amount of goods traded (in US$) in Iraq in 2010 to that in 2011?
Give a very brief answer. 0.92. What is the ratio of the Amount of goods traded (in US$) of Canada in 2010 to that in 2012?
Provide a short and direct response. 0.85. What is the ratio of the Amount of goods traded (in US$) in Cyprus in 2010 to that in 2012?
Your response must be concise. 1.14. What is the ratio of the Amount of goods traded (in US$) in Iraq in 2010 to that in 2012?
Make the answer very short. 0.74. What is the ratio of the Amount of goods traded (in US$) in Canada in 2011 to that in 2012?
Your response must be concise. 0.97. What is the ratio of the Amount of goods traded (in US$) of Cyprus in 2011 to that in 2012?
Provide a short and direct response. 1.18. What is the ratio of the Amount of goods traded (in US$) in Iraq in 2011 to that in 2012?
Offer a terse response. 0.81. What is the difference between the highest and the second highest Amount of goods traded (in US$) of Canada?
Your answer should be compact. 1.37e+1. What is the difference between the highest and the second highest Amount of goods traded (in US$) of Cyprus?
Give a very brief answer. 1.98e+09. What is the difference between the highest and the second highest Amount of goods traded (in US$) of Iraq?
Your answer should be very brief. 9.52e+09. What is the difference between the highest and the lowest Amount of goods traded (in US$) in Canada?
Provide a succinct answer. 1.55e+11. What is the difference between the highest and the lowest Amount of goods traded (in US$) in Cyprus?
Offer a very short reply. 4.15e+09. What is the difference between the highest and the lowest Amount of goods traded (in US$) of Iraq?
Offer a very short reply. 3.35e+1. 